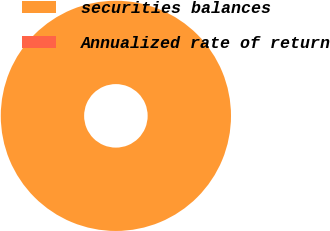Convert chart. <chart><loc_0><loc_0><loc_500><loc_500><pie_chart><fcel>securities balances<fcel>Annualized rate of return<nl><fcel>100.0%<fcel>0.0%<nl></chart> 